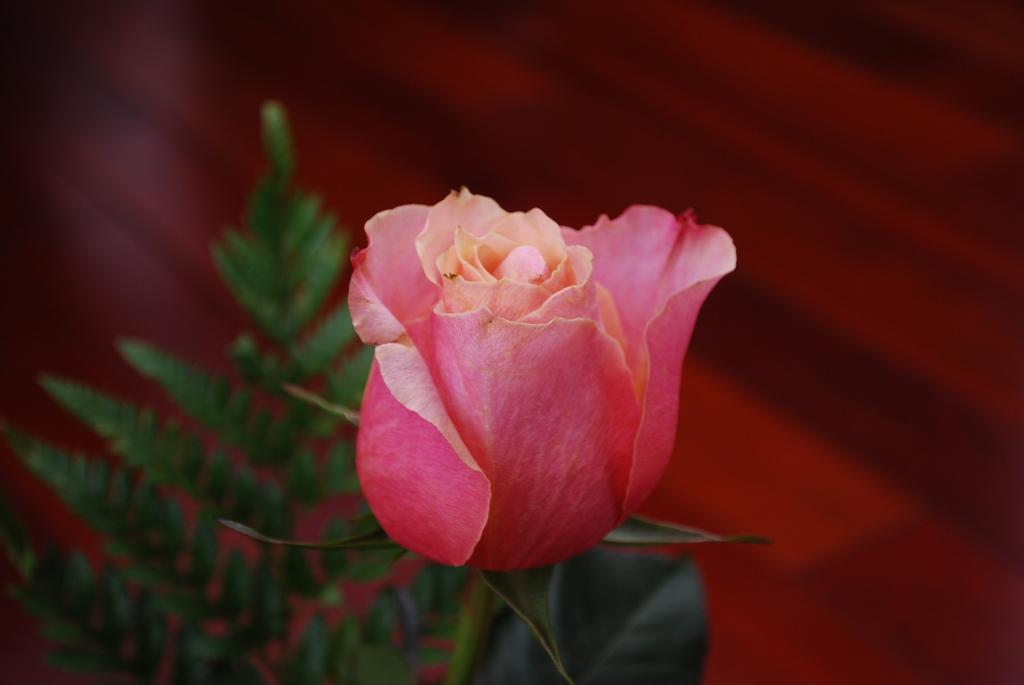What type of flower is present in the image? There is a pink color flower in the image. What else can be seen in the image besides the flower? There are leaves visible in the image. What type of jam is being spread on the spark in the image? There is no jam or spark present in the image; it only features a pink color flower and leaves. 